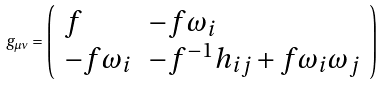<formula> <loc_0><loc_0><loc_500><loc_500>g _ { \mu \nu } = \left ( \begin{array} { l l } { f } & { { - f \omega _ { i } } } \\ { { - f \omega _ { i } } } & { { - f ^ { - 1 } h _ { i j } + f \omega _ { i } \omega _ { j } } } \end{array} \right )</formula> 